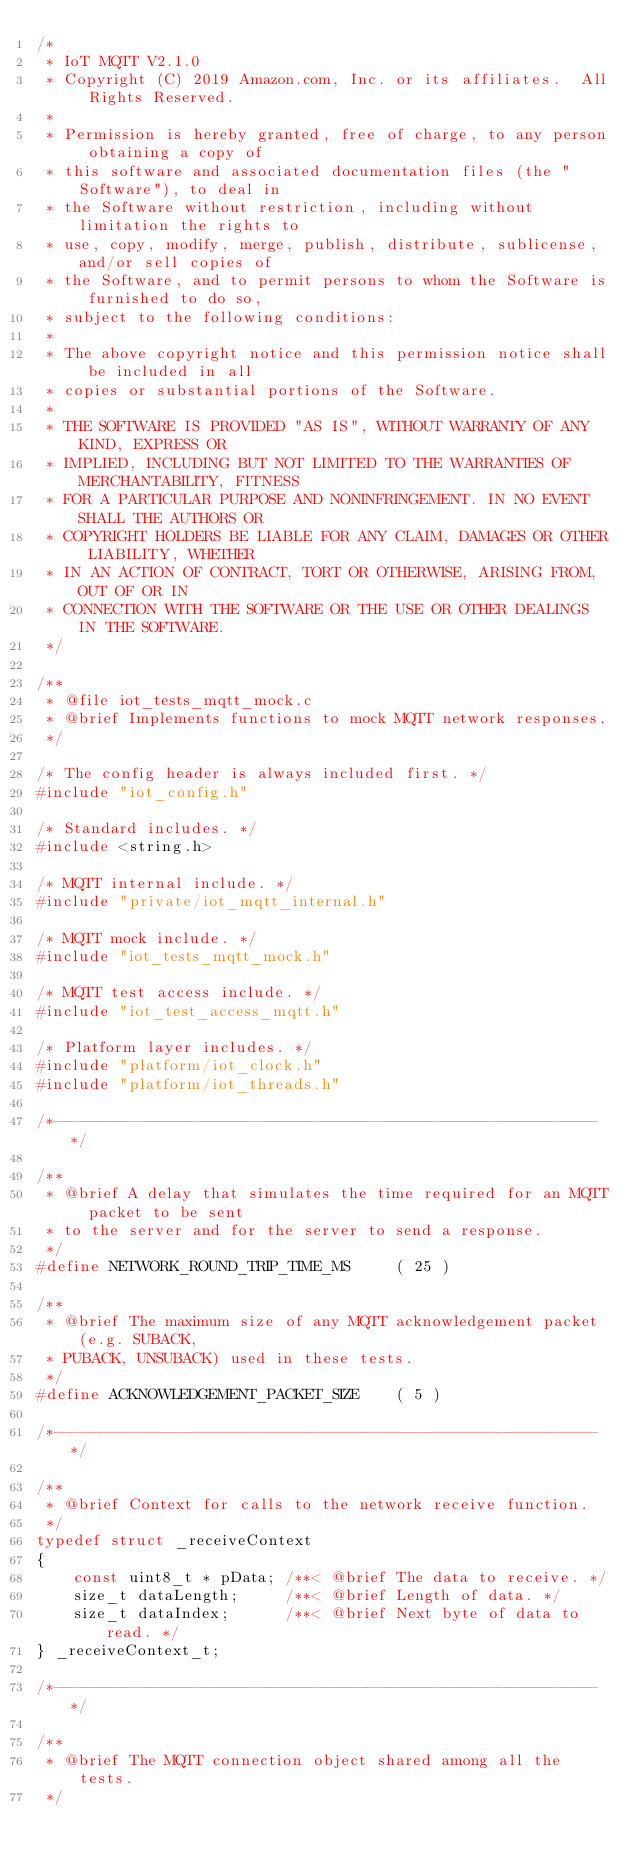Convert code to text. <code><loc_0><loc_0><loc_500><loc_500><_C_>/*
 * IoT MQTT V2.1.0
 * Copyright (C) 2019 Amazon.com, Inc. or its affiliates.  All Rights Reserved.
 *
 * Permission is hereby granted, free of charge, to any person obtaining a copy of
 * this software and associated documentation files (the "Software"), to deal in
 * the Software without restriction, including without limitation the rights to
 * use, copy, modify, merge, publish, distribute, sublicense, and/or sell copies of
 * the Software, and to permit persons to whom the Software is furnished to do so,
 * subject to the following conditions:
 *
 * The above copyright notice and this permission notice shall be included in all
 * copies or substantial portions of the Software.
 *
 * THE SOFTWARE IS PROVIDED "AS IS", WITHOUT WARRANTY OF ANY KIND, EXPRESS OR
 * IMPLIED, INCLUDING BUT NOT LIMITED TO THE WARRANTIES OF MERCHANTABILITY, FITNESS
 * FOR A PARTICULAR PURPOSE AND NONINFRINGEMENT. IN NO EVENT SHALL THE AUTHORS OR
 * COPYRIGHT HOLDERS BE LIABLE FOR ANY CLAIM, DAMAGES OR OTHER LIABILITY, WHETHER
 * IN AN ACTION OF CONTRACT, TORT OR OTHERWISE, ARISING FROM, OUT OF OR IN
 * CONNECTION WITH THE SOFTWARE OR THE USE OR OTHER DEALINGS IN THE SOFTWARE.
 */

/**
 * @file iot_tests_mqtt_mock.c
 * @brief Implements functions to mock MQTT network responses.
 */

/* The config header is always included first. */
#include "iot_config.h"

/* Standard includes. */
#include <string.h>

/* MQTT internal include. */
#include "private/iot_mqtt_internal.h"

/* MQTT mock include. */
#include "iot_tests_mqtt_mock.h"

/* MQTT test access include. */
#include "iot_test_access_mqtt.h"

/* Platform layer includes. */
#include "platform/iot_clock.h"
#include "platform/iot_threads.h"

/*-----------------------------------------------------------*/

/**
 * @brief A delay that simulates the time required for an MQTT packet to be sent
 * to the server and for the server to send a response.
 */
#define NETWORK_ROUND_TRIP_TIME_MS     ( 25 )

/**
 * @brief The maximum size of any MQTT acknowledgement packet (e.g. SUBACK,
 * PUBACK, UNSUBACK) used in these tests.
 */
#define ACKNOWLEDGEMENT_PACKET_SIZE    ( 5 )

/*-----------------------------------------------------------*/

/**
 * @brief Context for calls to the network receive function.
 */
typedef struct _receiveContext
{
    const uint8_t * pData; /**< @brief The data to receive. */
    size_t dataLength;     /**< @brief Length of data. */
    size_t dataIndex;      /**< @brief Next byte of data to read. */
} _receiveContext_t;

/*-----------------------------------------------------------*/

/**
 * @brief The MQTT connection object shared among all the tests.
 */</code> 